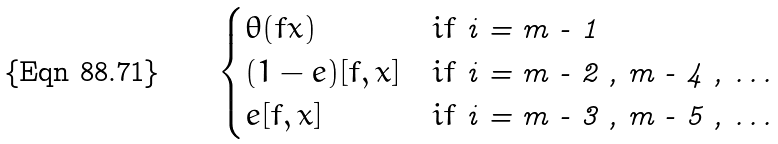<formula> <loc_0><loc_0><loc_500><loc_500>\begin{cases} \theta ( f x ) & i f $ i = m - 1 $ \\ ( 1 - e ) [ f , x ] & i f $ i = m - 2 , m - 4 , \dots $ \\ e [ f , x ] & i f $ i = m - 3 , m - 5 , \dots $ \end{cases}</formula> 